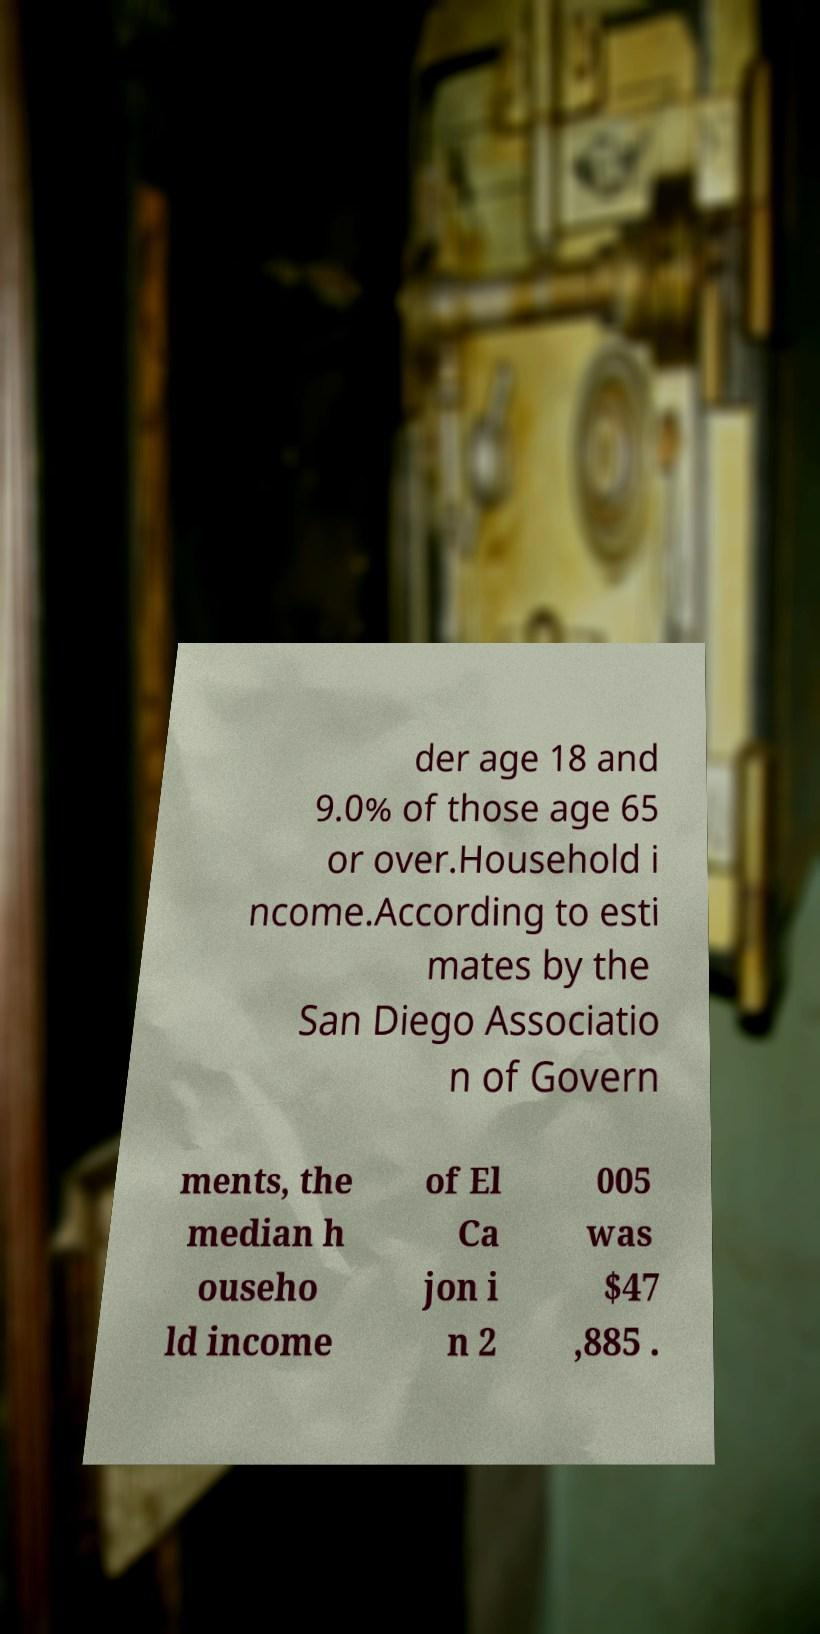Please identify and transcribe the text found in this image. der age 18 and 9.0% of those age 65 or over.Household i ncome.According to esti mates by the San Diego Associatio n of Govern ments, the median h ouseho ld income of El Ca jon i n 2 005 was $47 ,885 . 